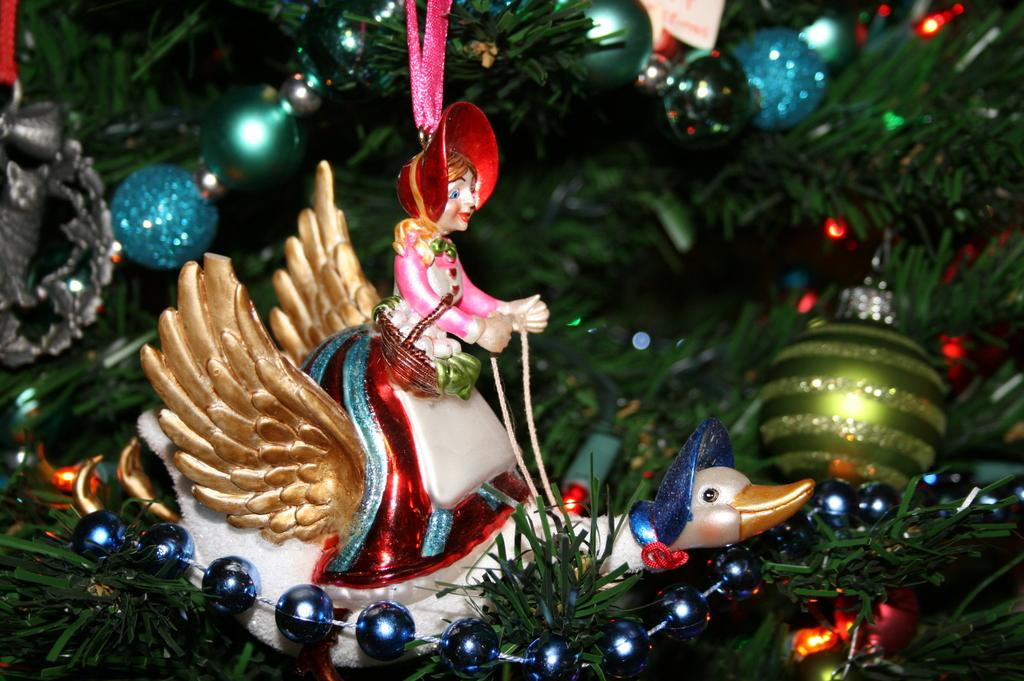What is the main object in the foreground of the image? There is a tree in the image, with balls and stars attached to it, and a toy of a lady person sitting on a bird. What is the lady person doing in the toy? The lady person is sitting on a bird in the toy. What is the position of the tree, balls, stars, and toy in the image? They are all at the foreground of the image. What type of key is used to unlock the jar in the image? There is no key or jar present in the image. 